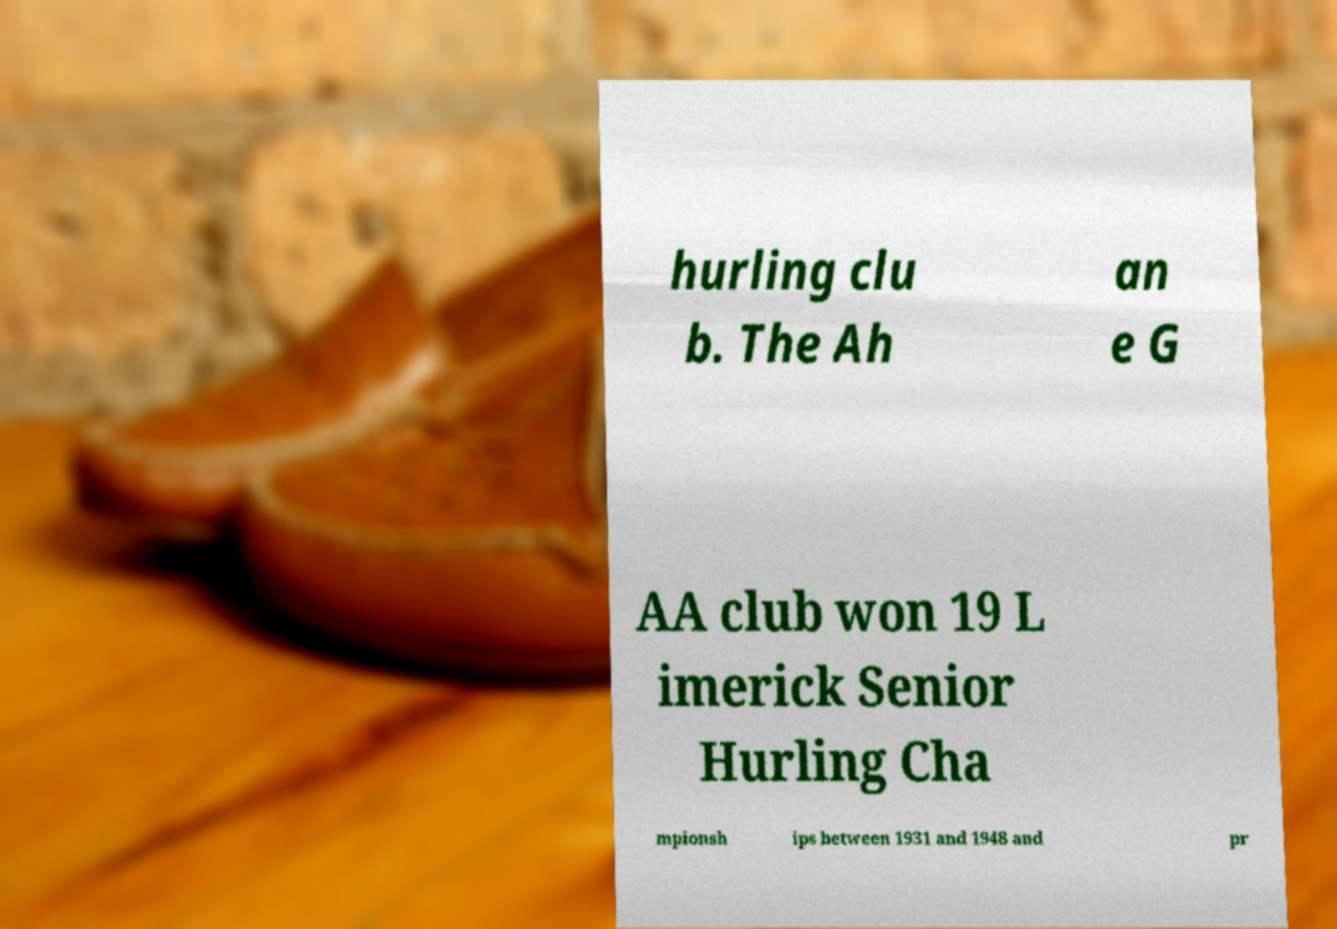Please identify and transcribe the text found in this image. hurling clu b. The Ah an e G AA club won 19 L imerick Senior Hurling Cha mpionsh ips between 1931 and 1948 and pr 